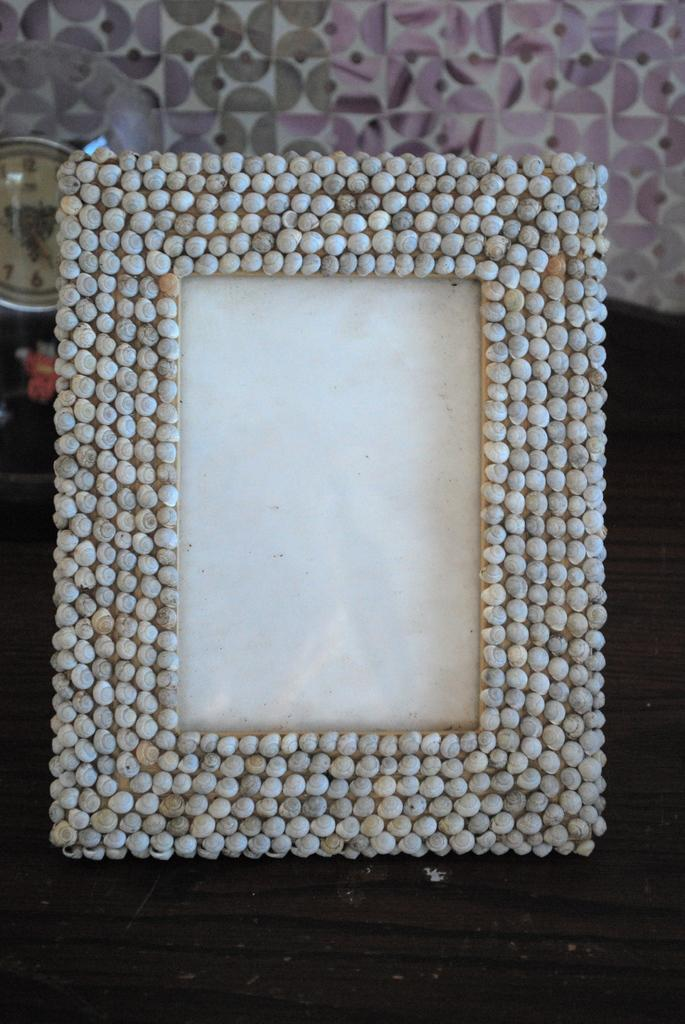What is the main object in the center of the image? There is a photo frame in the center of the image. Where is the photo frame located? The photo frame is placed on a table. What can be seen in the background of the image? There is a clock and a wall in the background of the image. How many sheep are visible in the image? There are no sheep present in the image. What type of screw is used to hold the photo frame together? The photo frame is not a physical object in the image, so it cannot be determined if it has any screws. 